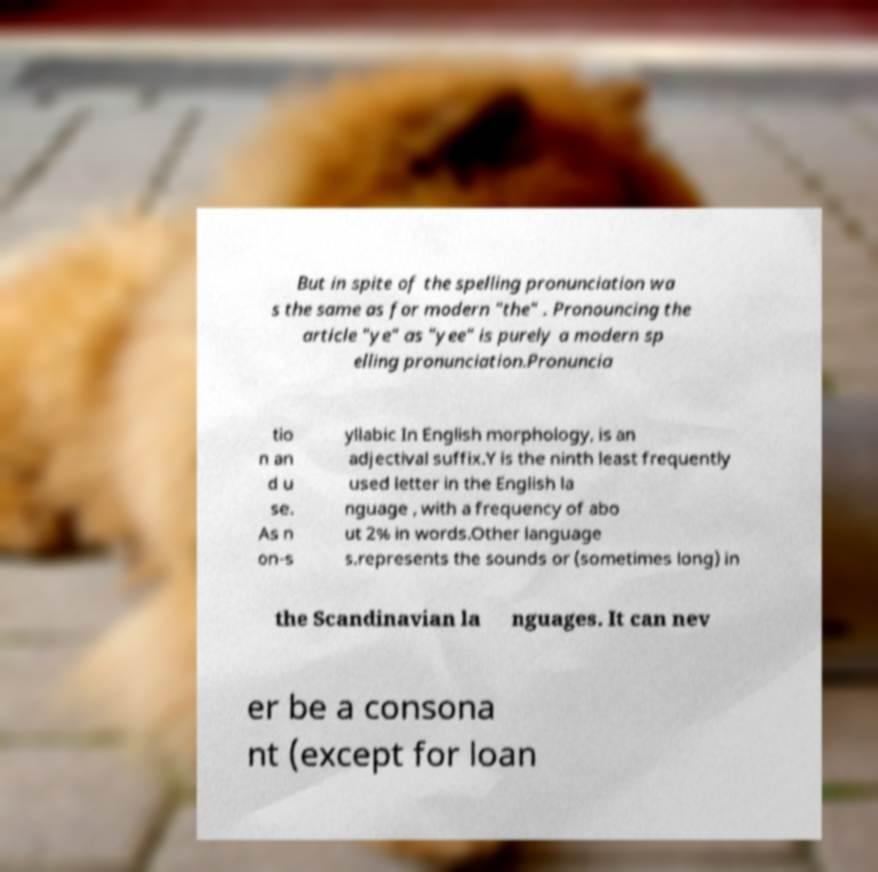Can you read and provide the text displayed in the image?This photo seems to have some interesting text. Can you extract and type it out for me? But in spite of the spelling pronunciation wa s the same as for modern "the" . Pronouncing the article "ye" as "yee" is purely a modern sp elling pronunciation.Pronuncia tio n an d u se. As n on-s yllabic In English morphology, is an adjectival suffix.Y is the ninth least frequently used letter in the English la nguage , with a frequency of abo ut 2% in words.Other language s.represents the sounds or (sometimes long) in the Scandinavian la nguages. It can nev er be a consona nt (except for loan 